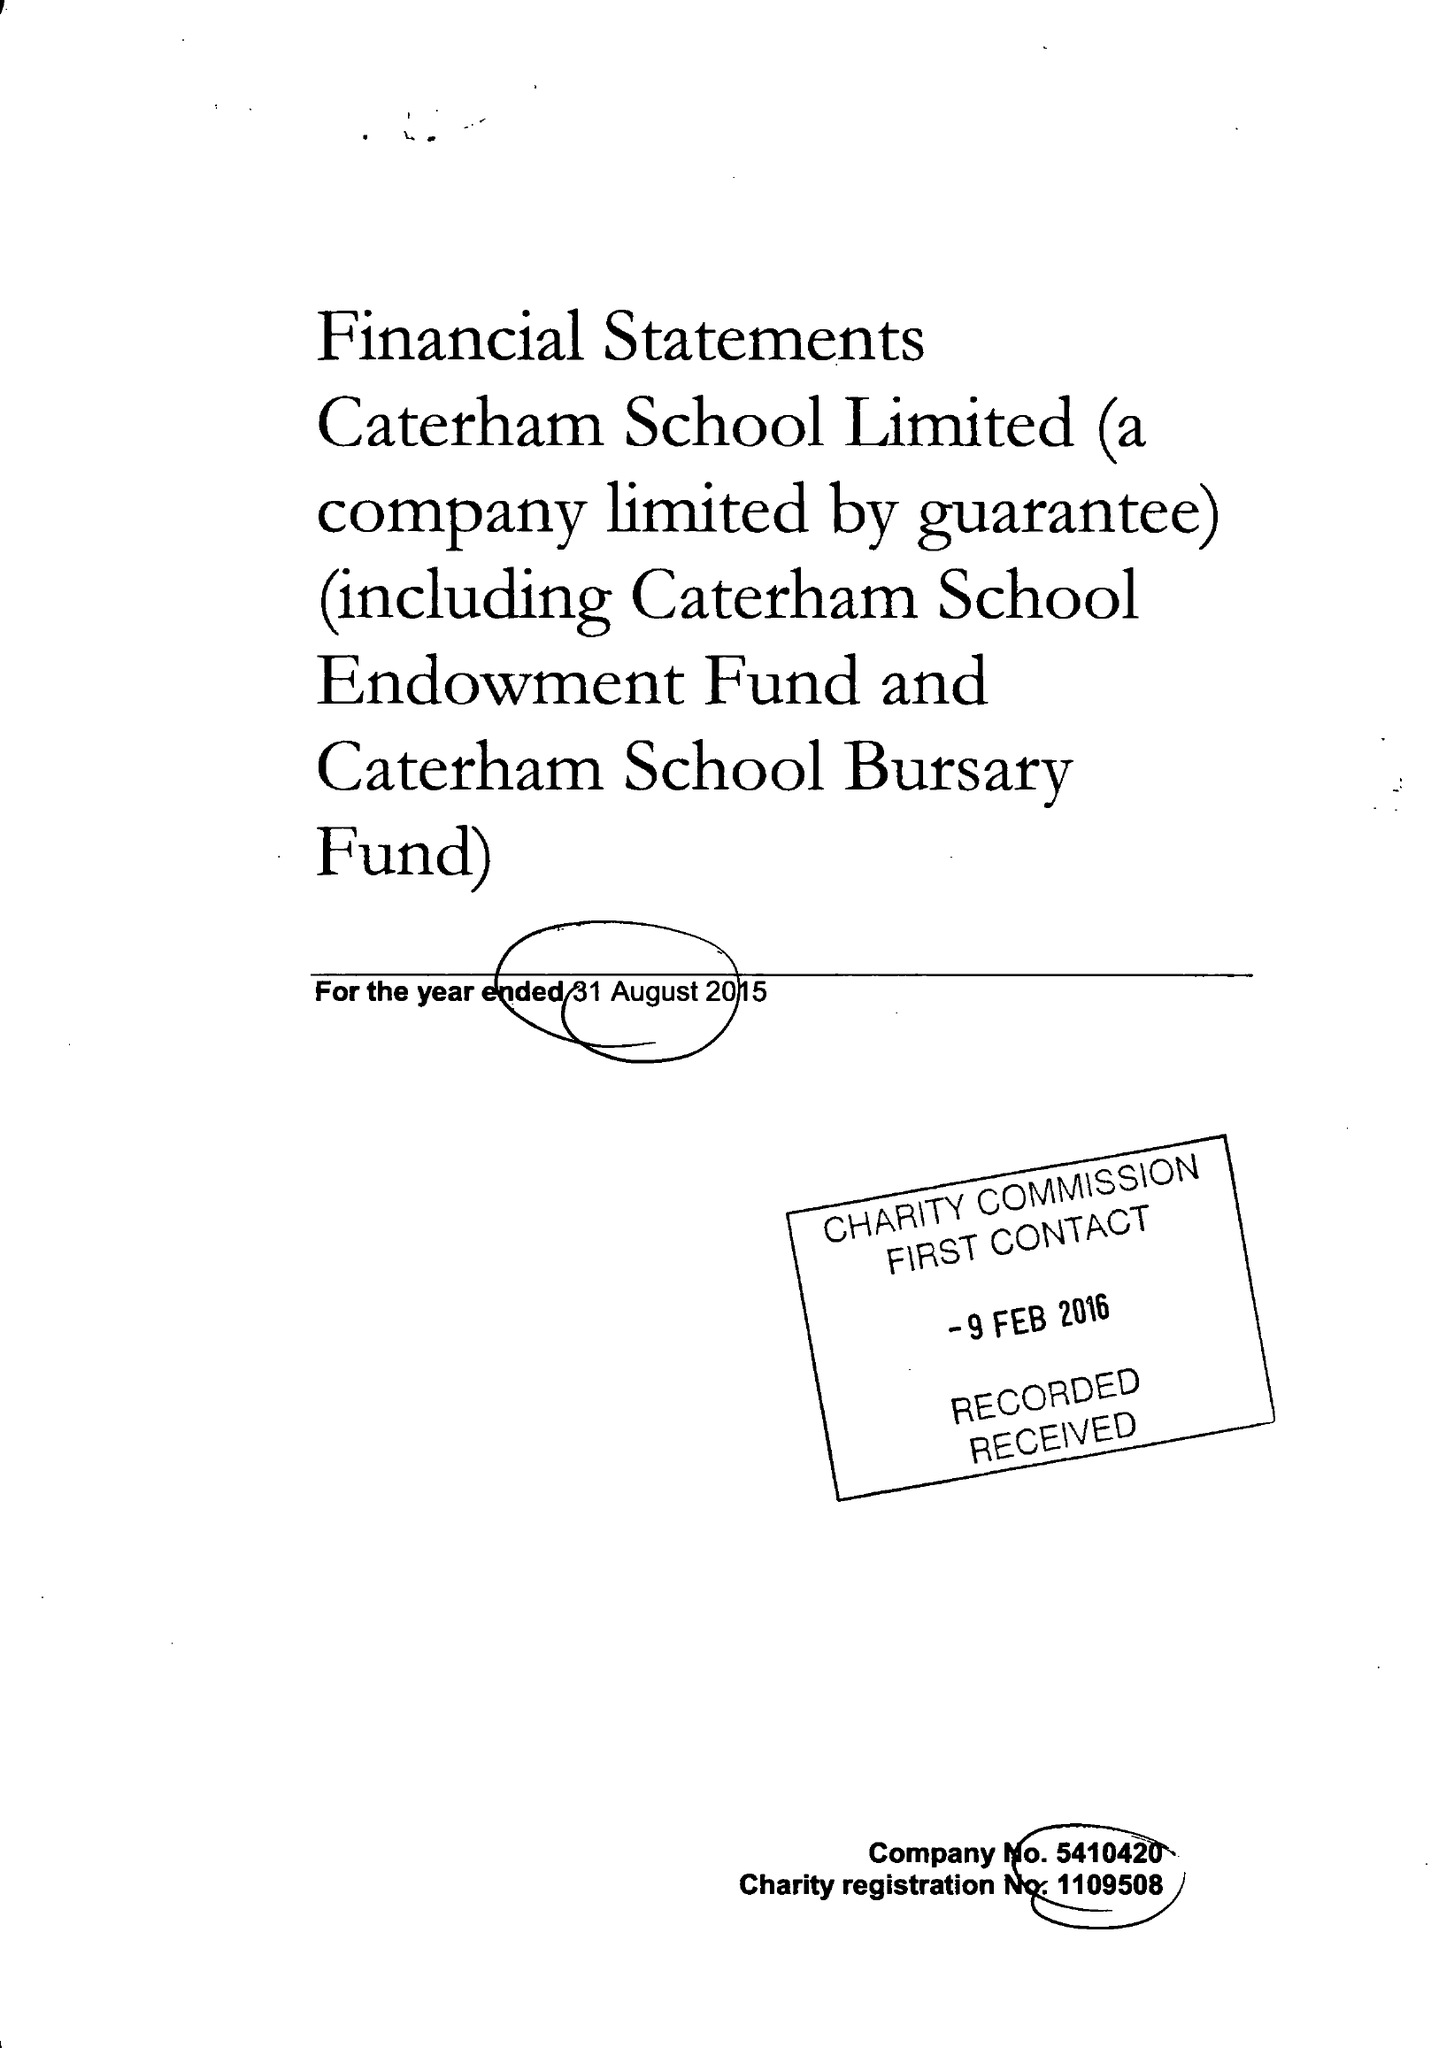What is the value for the address__street_line?
Answer the question using a single word or phrase. HARESTONE VALLEY ROAD 